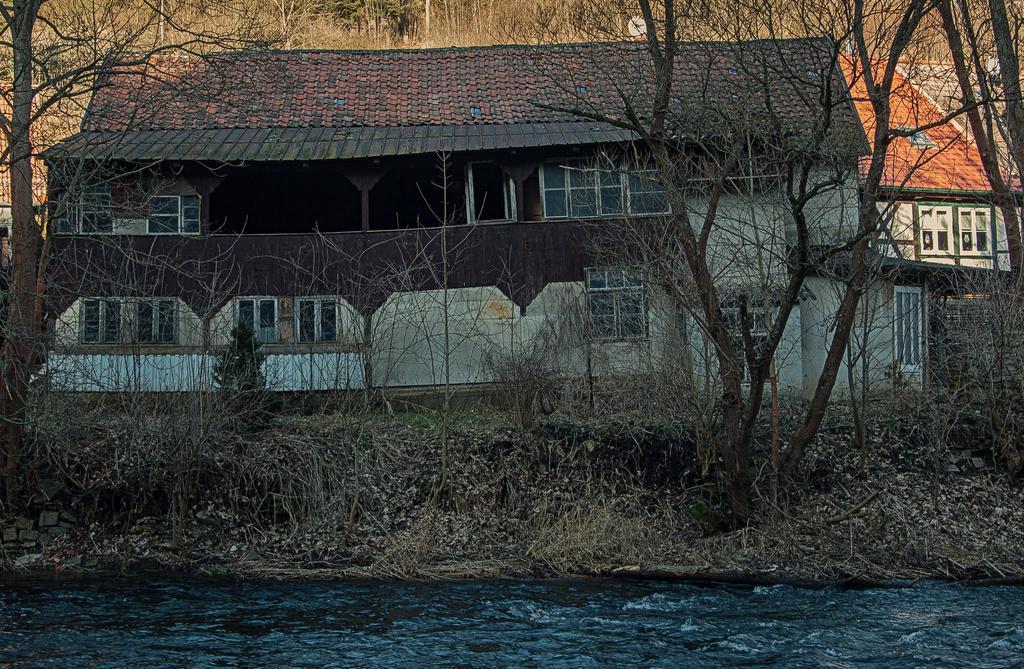In one or two sentences, can you explain what this image depicts? This picture is clicked outside. In the foreground we can see a water body and the dry stems, plants, trees and the houses. In the background we can see the trees and some other objects. 